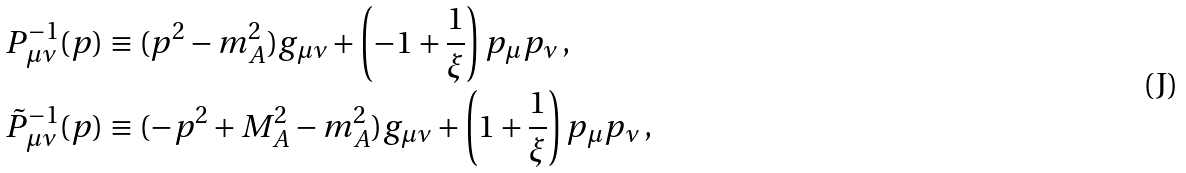Convert formula to latex. <formula><loc_0><loc_0><loc_500><loc_500>P ^ { - 1 } _ { \mu \nu } ( p ) & \equiv ( p ^ { 2 } - m _ { A } ^ { 2 } ) g _ { \mu \nu } + \left ( - 1 + \frac { 1 } { \xi } \right ) p _ { \mu } p _ { \nu } \, , \\ \tilde { P } ^ { - 1 } _ { \mu \nu } ( p ) & \equiv ( - p ^ { 2 } + M _ { A } ^ { 2 } - m _ { A } ^ { 2 } ) g _ { \mu \nu } + \left ( 1 + \frac { 1 } { \xi } \right ) p _ { \mu } p _ { \nu } \, ,</formula> 